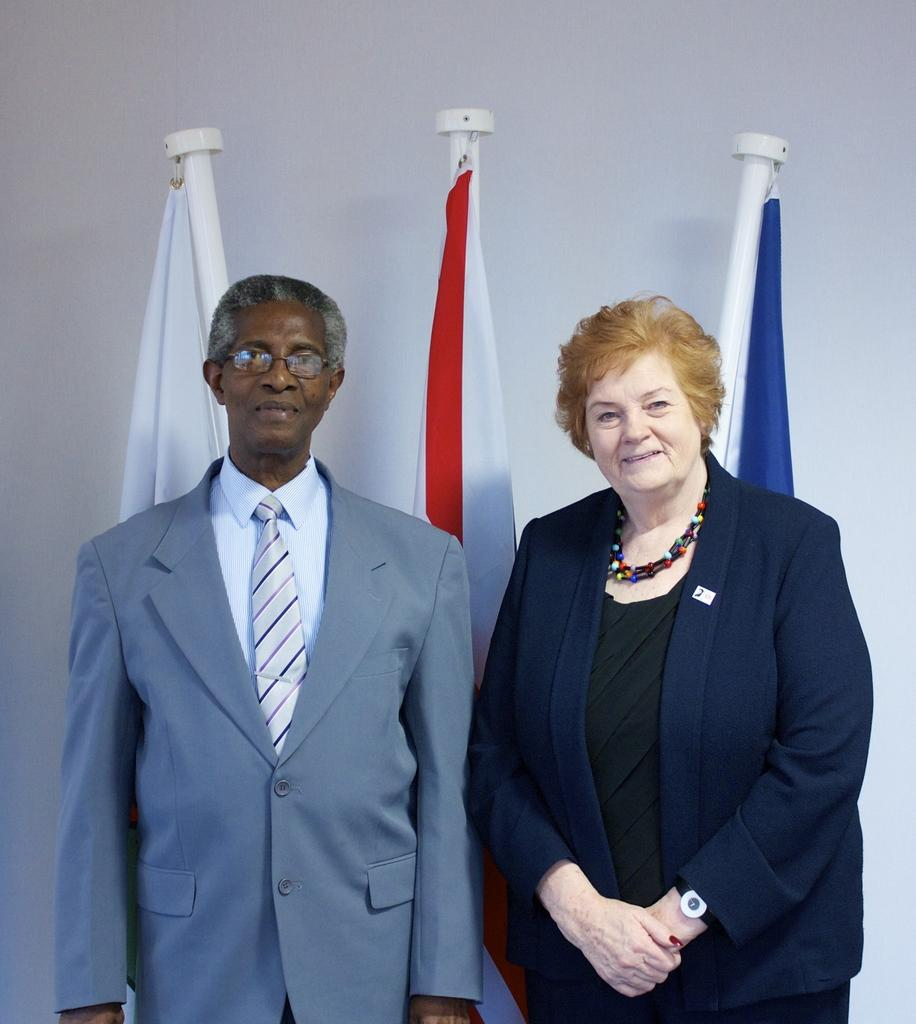How many people are present in the image? There are two people standing in the image. Where are the people standing? The people are standing on the floor. What can be seen in the background of the image? There are flags on poles and a white wall in the background of the image. What type of hand can be seen holding the flag in the image? There is no hand holding a flag in the image; the flags are on poles. Is the mother of the two people present in the image? The provided facts do not mention a mother or any familial relationships, so we cannot determine if the mother is present in the image. 